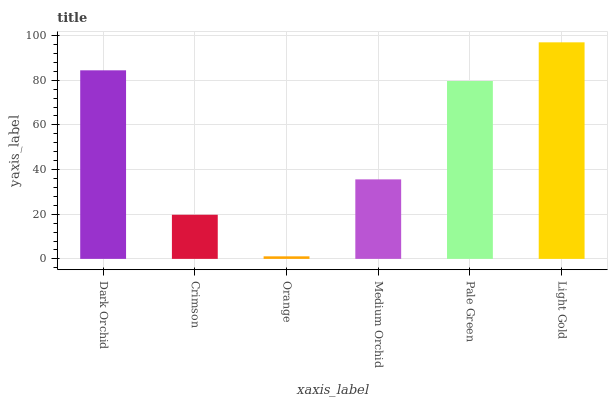Is Orange the minimum?
Answer yes or no. Yes. Is Light Gold the maximum?
Answer yes or no. Yes. Is Crimson the minimum?
Answer yes or no. No. Is Crimson the maximum?
Answer yes or no. No. Is Dark Orchid greater than Crimson?
Answer yes or no. Yes. Is Crimson less than Dark Orchid?
Answer yes or no. Yes. Is Crimson greater than Dark Orchid?
Answer yes or no. No. Is Dark Orchid less than Crimson?
Answer yes or no. No. Is Pale Green the high median?
Answer yes or no. Yes. Is Medium Orchid the low median?
Answer yes or no. Yes. Is Orange the high median?
Answer yes or no. No. Is Orange the low median?
Answer yes or no. No. 